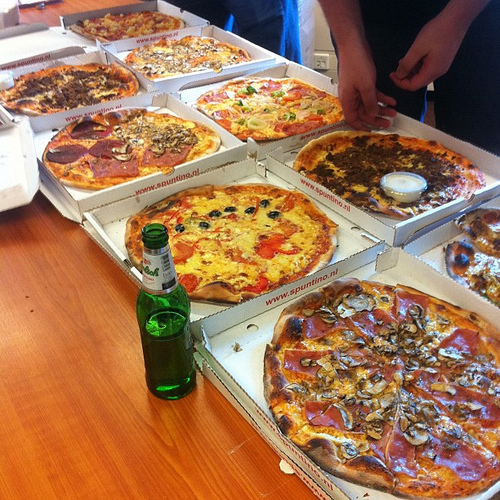Where in this photograph is the ham, on the left or on the right? The ham is on the left side of the photograph. 